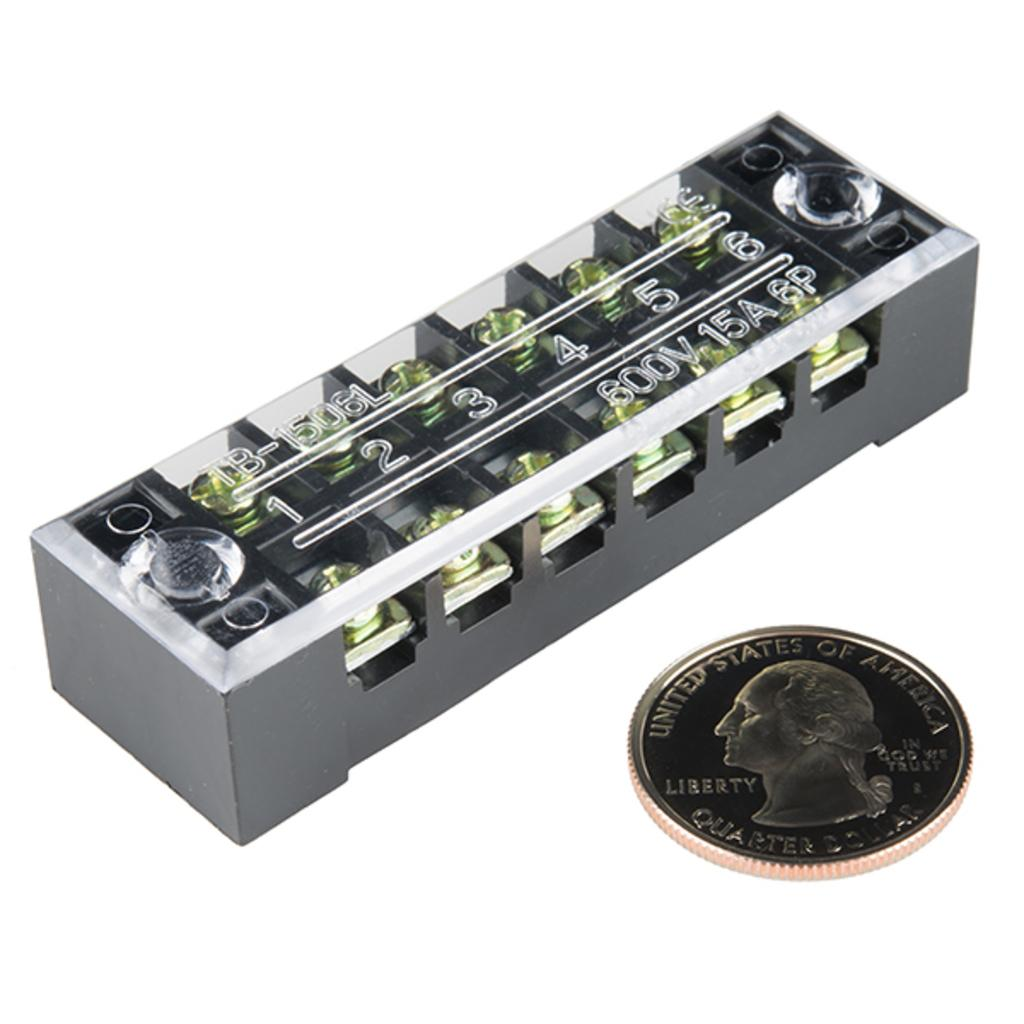What type of electrical component is shown in the image? There is a 6-way terminal block in the image. What other object is present in the image? There is a coin in the image. What color is the background of the image? The background of the image is white in color. What is the price of the teaching rock in the image? There is no teaching rock present in the image, and therefore no price can be determined. 